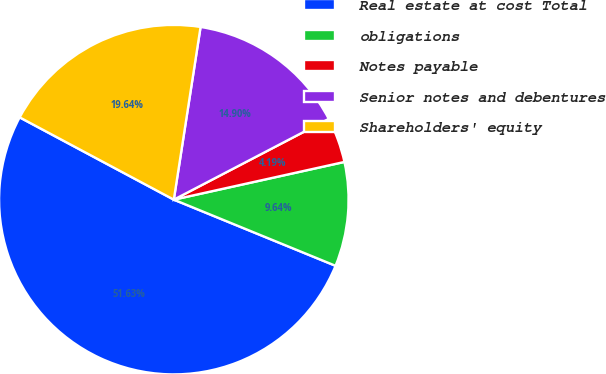<chart> <loc_0><loc_0><loc_500><loc_500><pie_chart><fcel>Real estate at cost Total<fcel>obligations<fcel>Notes payable<fcel>Senior notes and debentures<fcel>Shareholders' equity<nl><fcel>51.62%<fcel>9.64%<fcel>4.19%<fcel>14.9%<fcel>19.64%<nl></chart> 